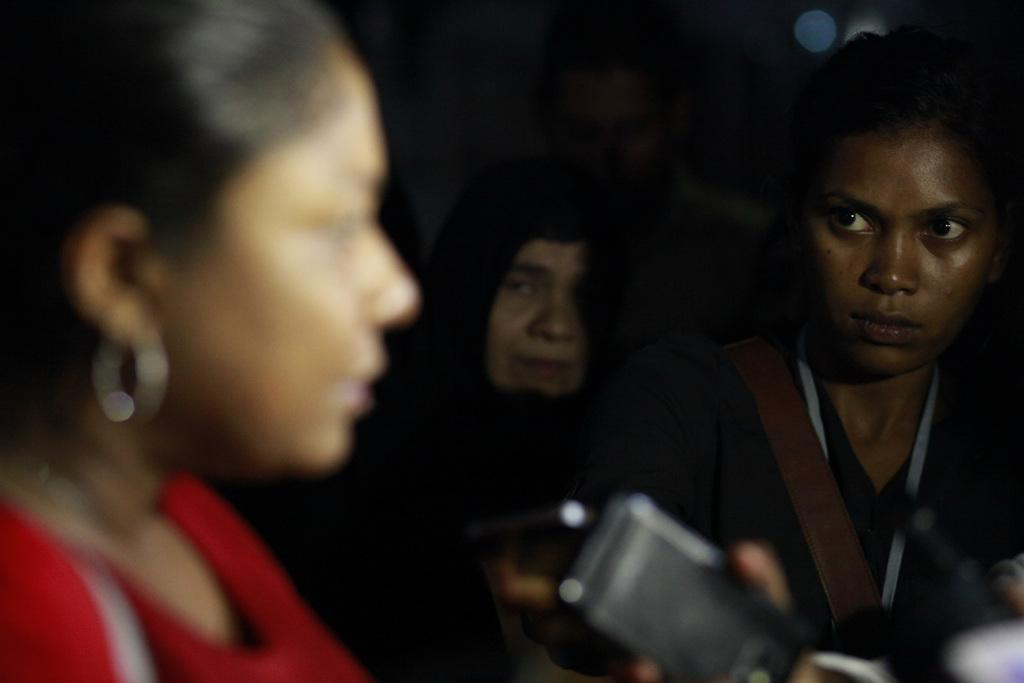Who or what can be seen in the image? There are people in the image. What are the people doing in the image? The people are holding objects in their hands. Can you describe the background of the image? The background of the image is blurred. What type of branch can be seen in the image? There is no branch present in the image. Is there any indication of flight in the image? There is no indication of flight in the image. 